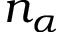<formula> <loc_0><loc_0><loc_500><loc_500>n _ { \alpha }</formula> 